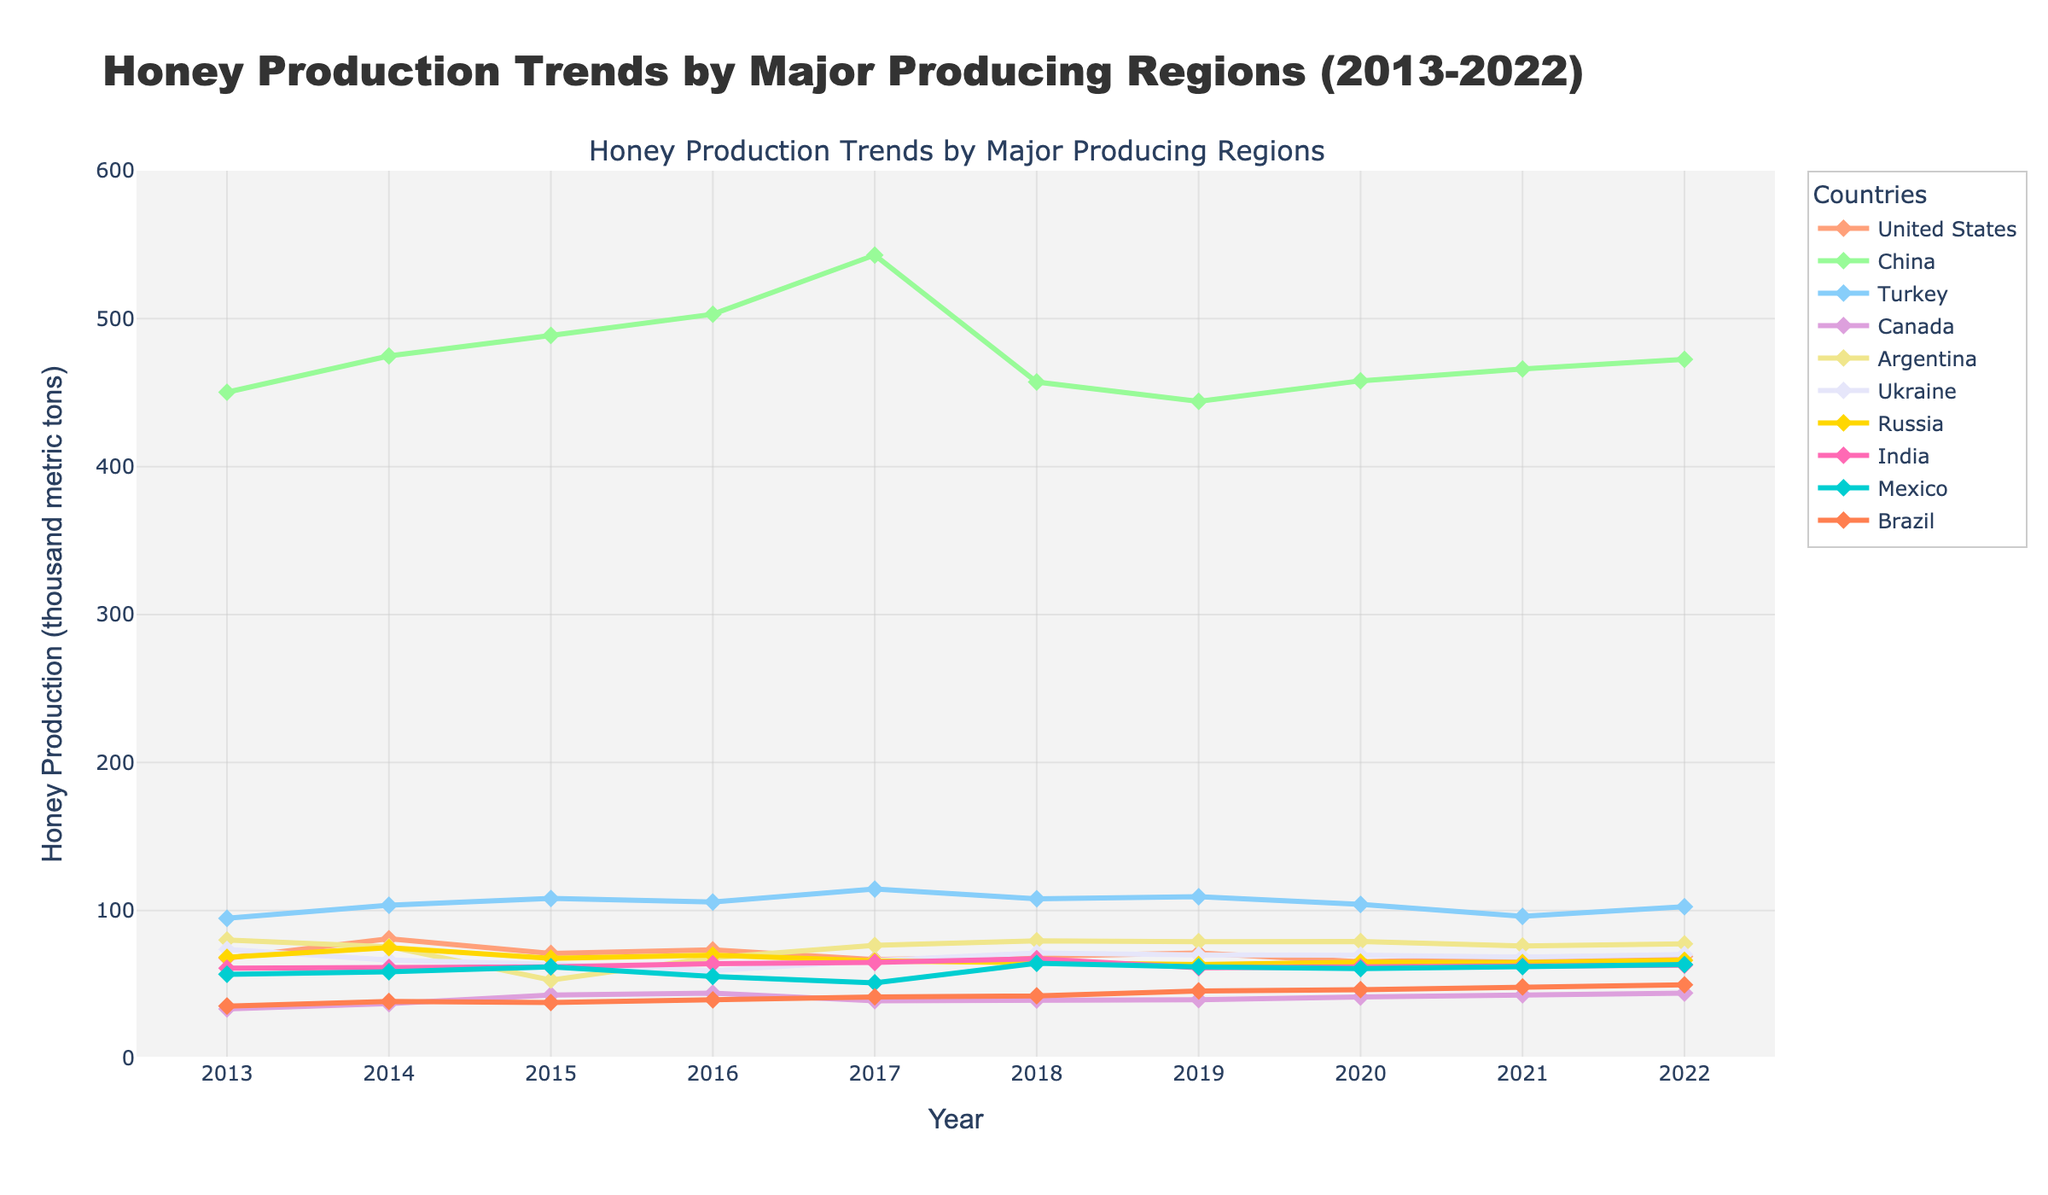Which region had the highest honey production in 2022? To find the region with the highest honey production in 2022, look at the y-values corresponding to the year 2022 for each line. The highest y-value belongs to China.
Answer: China How did honey production in the United States change from 2013 to 2022? Check the y-values for the United States in 2013 and 2022. In 2013, it was 67.8, and in 2022, it was 68.9. The production slightly increased over this period.
Answer: Slightly increased What was the average honey production in Turkey from 2013 to 2022? Sum the honey production values for Turkey from 2013 to 2022 and divide by the number of years (10). The sum is 941.2, so the average is 941.2 / 10 = 94.12.
Answer: 94.12 Which two regions had the closest honey production levels in 2022? Compare the y-values for all regions in 2022. Ukraine (70.2) and the United States (68.9) are the closest.
Answer: Ukraine and United States By how much did honey production in Canada increase from 2013 to 2022? Subtract Canada's 2013 honey production from its 2022 value. In 2013, it was 33.5, and in 2022, it was 44.2. 44.2 - 33.5 = 10.7.
Answer: 10.7 Which region saw the most variability in honey production from 2013 to 2022? Look for the region with the largest fluctuations in y-values over the years. China shows the highest variability, with significant increases and decreases over the decade.
Answer: China What was the total honey production in 2018? Sum the honey production values for all regions in 2018. The sum is 69.1 + 457.2 + 107.9 + 39.5 + 79.5 + 71.3 + 65.0 + 67.4 + 64.3 + 42.3 = 1063.5.
Answer: 1063.5 Which year's production was greater for Mexico: 2016 or 2019? Check the y-values for Mexico in 2016 and 2019. In 2016, it was 55.4, and in 2019, it was 61.9. 61.9 > 55.4.
Answer: 2019 Which region had a peak production year in 2017? Look for the highest y-value for each region. Turkey had its highest production in 2017 with the value of 114.5.
Answer: Turkey What is the average change in honey production for Argentina from 2013 to 2022? Calculate the difference in production for each consecutive year in Argentina, sum these differences, and divide by the number of intervals (9). The differences are -4.5, -22.5, +15.1, +8.3, +3.1, -0.6, +1.0, -2.0, +1.5. The sum is -0.6, so the average change is -0.6 / 9 ≈ -0.067.
Answer: -0.067 